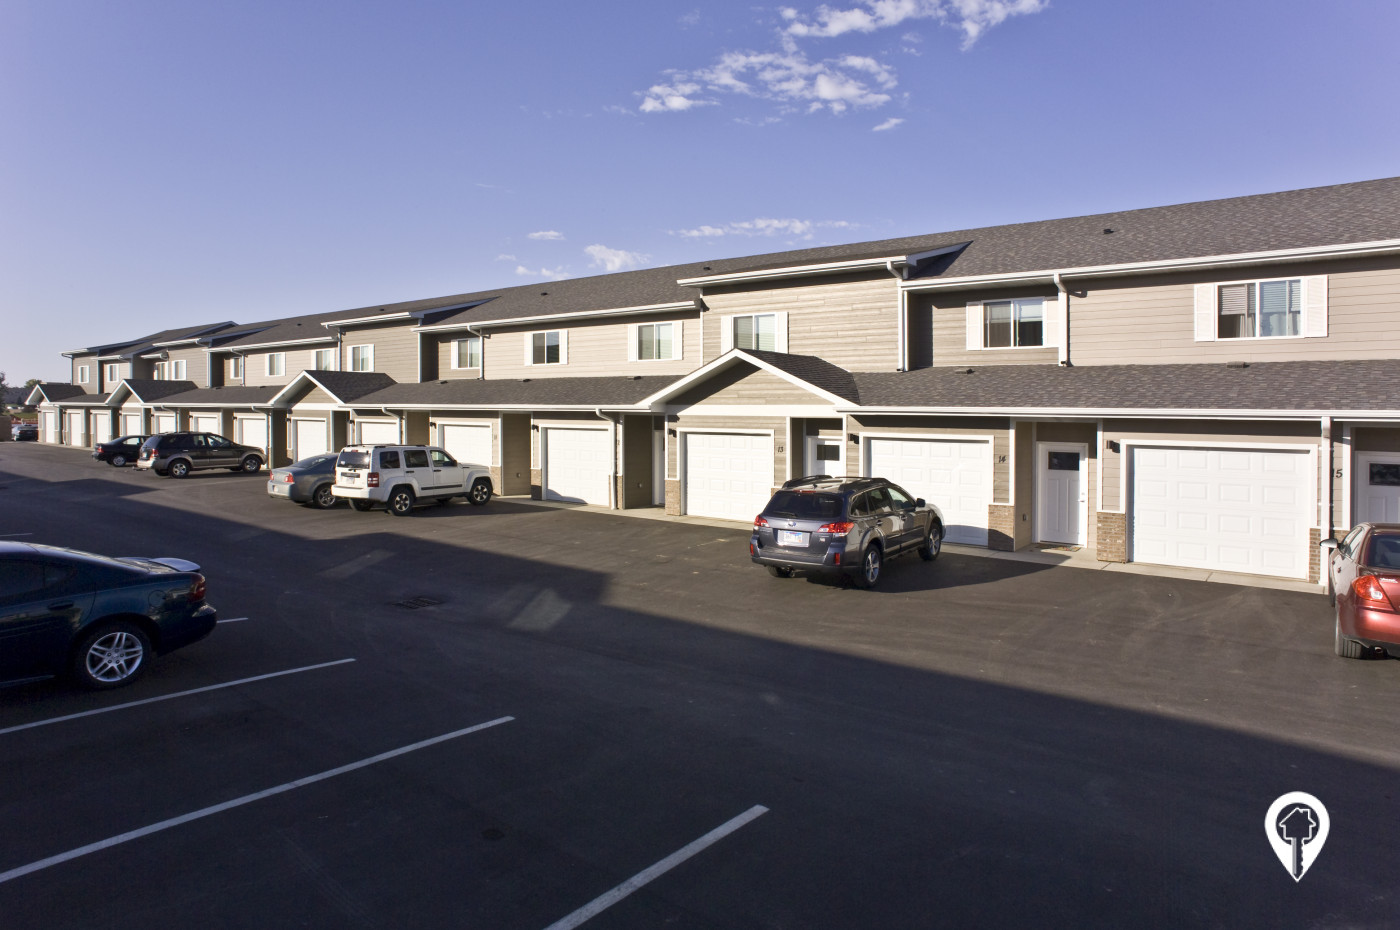Analyze the planning of the parking spaces in the community. Is it space-efficient? The layout of the parking lot in the image shows a straightforward, grid-like arrangement with marked parking spaces directly in front of townhouses. This efficient use of space ensures that each resident likely has access to at least one parking spot right outside their home, which minimizes distant walking and maximizes convenience. However, the arrangement provides little space for additional visitor parking, which could be a limitation during gatherings. 